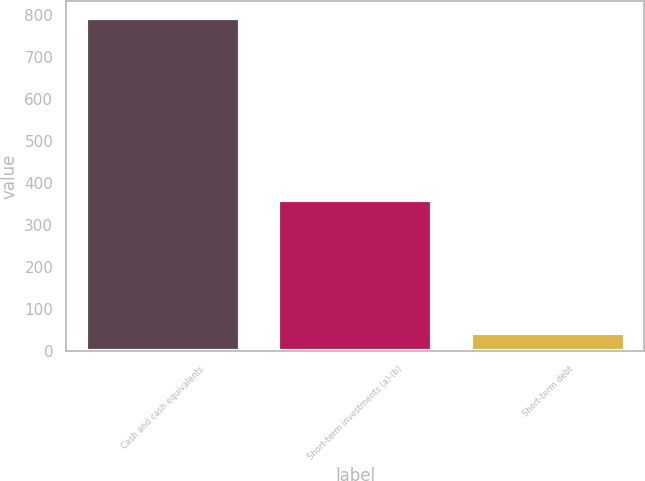Convert chart to OTSL. <chart><loc_0><loc_0><loc_500><loc_500><bar_chart><fcel>Cash and cash equivalents<fcel>Short-term investments (a) (b)<fcel>Short-term debt<nl><fcel>794<fcel>359<fcel>42<nl></chart> 